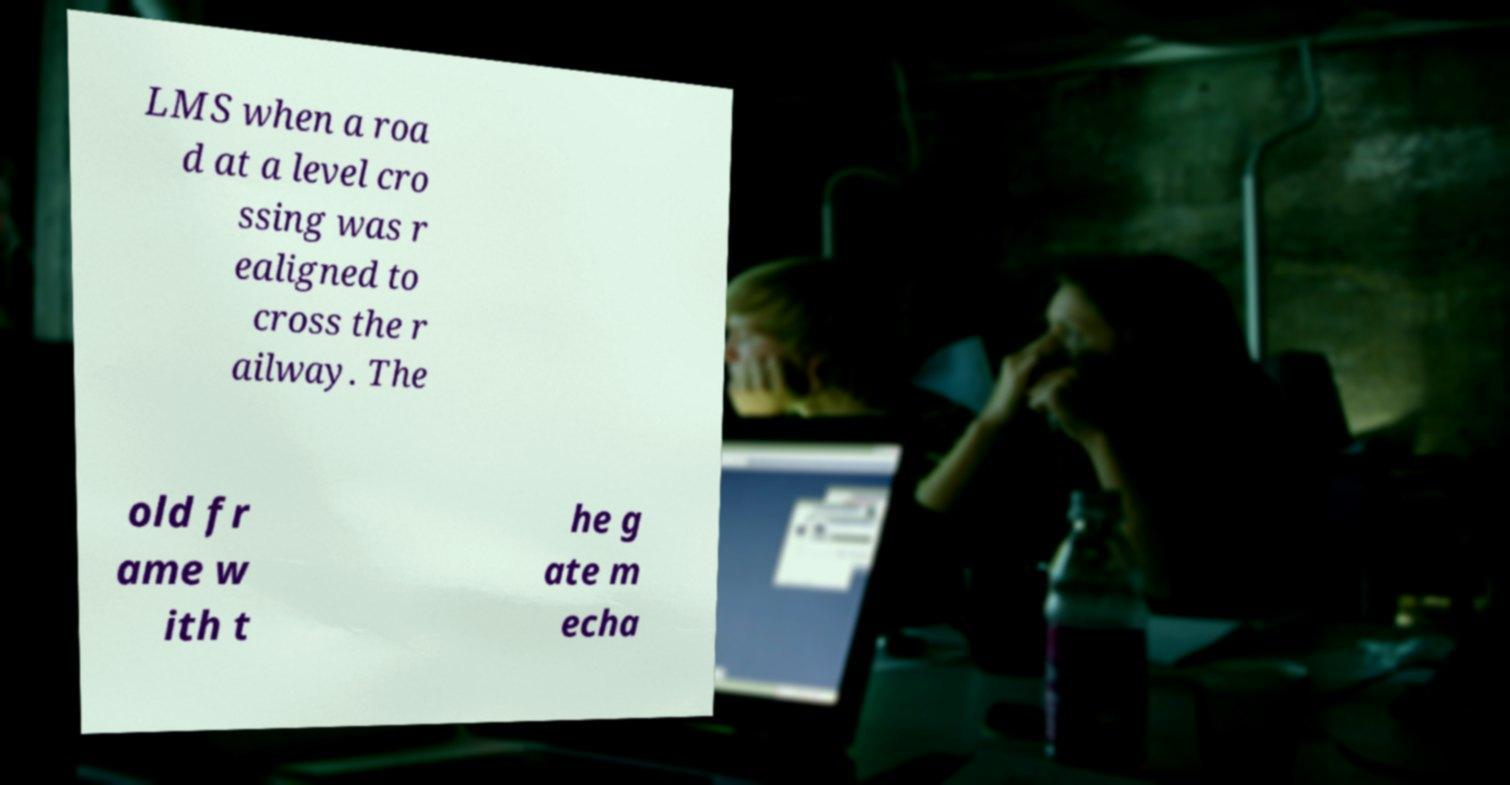What messages or text are displayed in this image? I need them in a readable, typed format. LMS when a roa d at a level cro ssing was r ealigned to cross the r ailway. The old fr ame w ith t he g ate m echa 